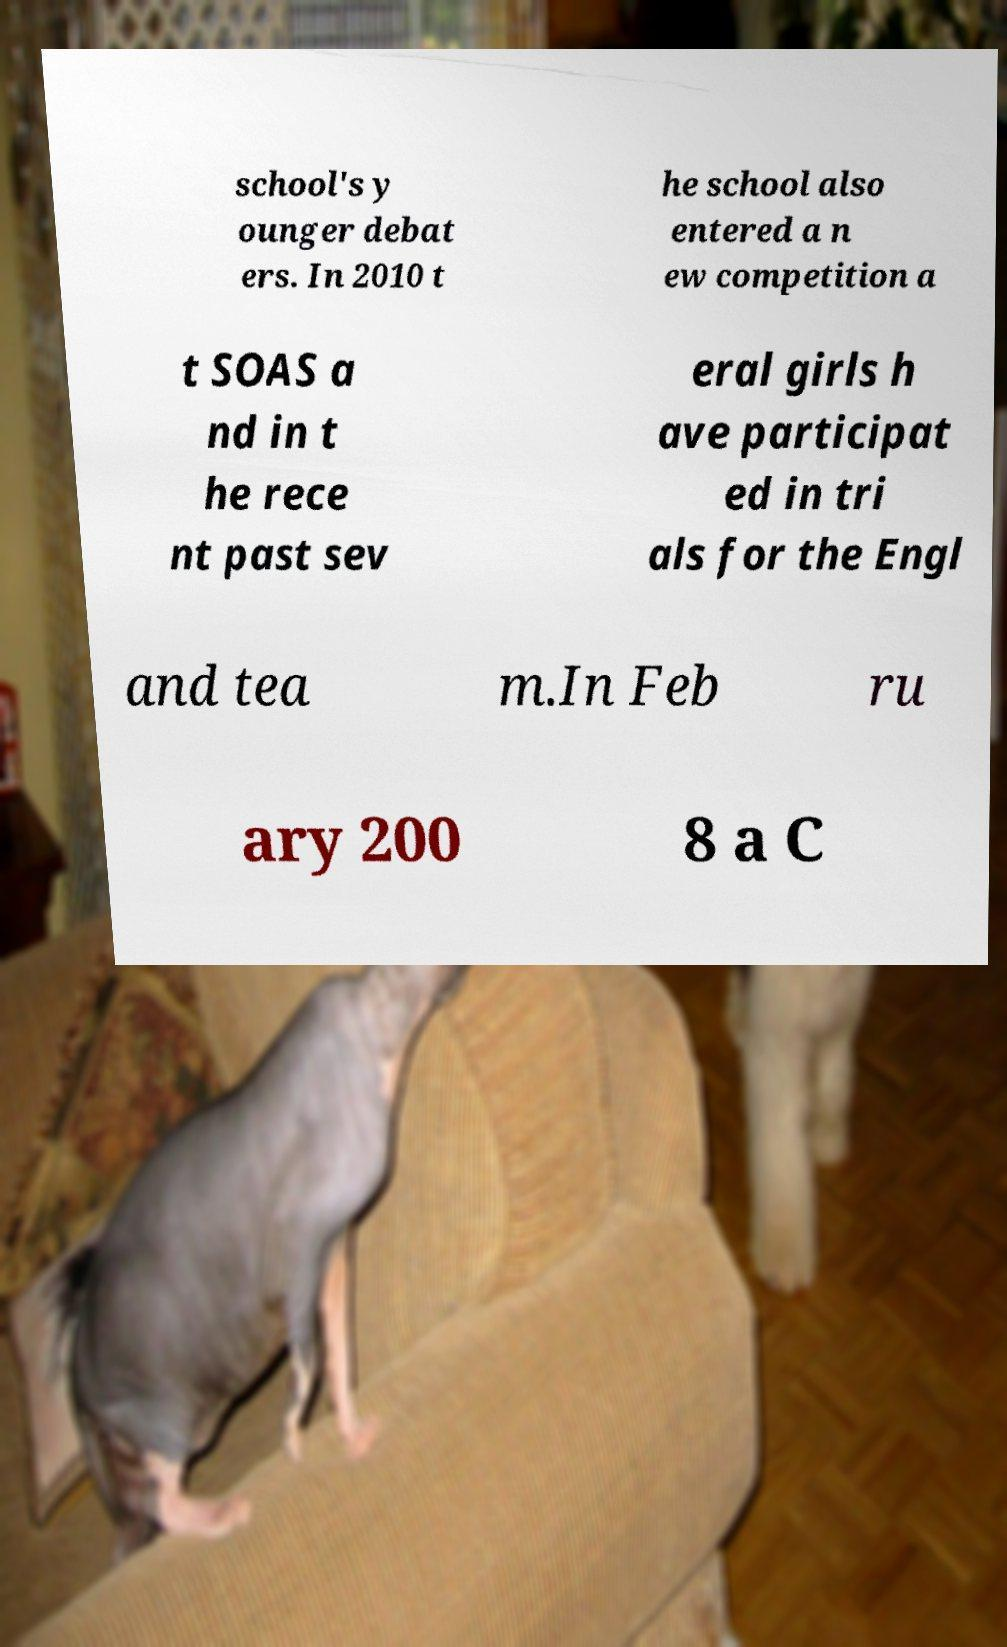Please identify and transcribe the text found in this image. school's y ounger debat ers. In 2010 t he school also entered a n ew competition a t SOAS a nd in t he rece nt past sev eral girls h ave participat ed in tri als for the Engl and tea m.In Feb ru ary 200 8 a C 